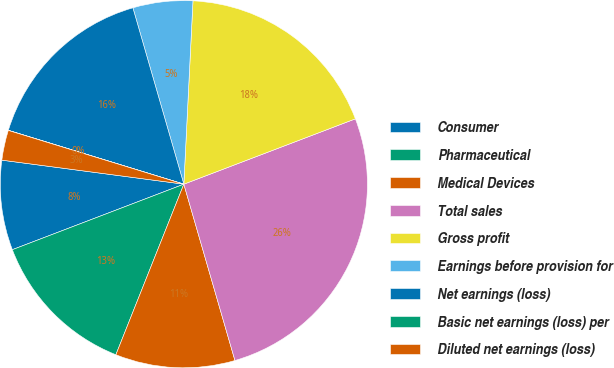Convert chart to OTSL. <chart><loc_0><loc_0><loc_500><loc_500><pie_chart><fcel>Consumer<fcel>Pharmaceutical<fcel>Medical Devices<fcel>Total sales<fcel>Gross profit<fcel>Earnings before provision for<fcel>Net earnings (loss)<fcel>Basic net earnings (loss) per<fcel>Diluted net earnings (loss)<nl><fcel>7.9%<fcel>13.16%<fcel>10.53%<fcel>26.31%<fcel>18.42%<fcel>5.27%<fcel>15.79%<fcel>0.01%<fcel>2.64%<nl></chart> 